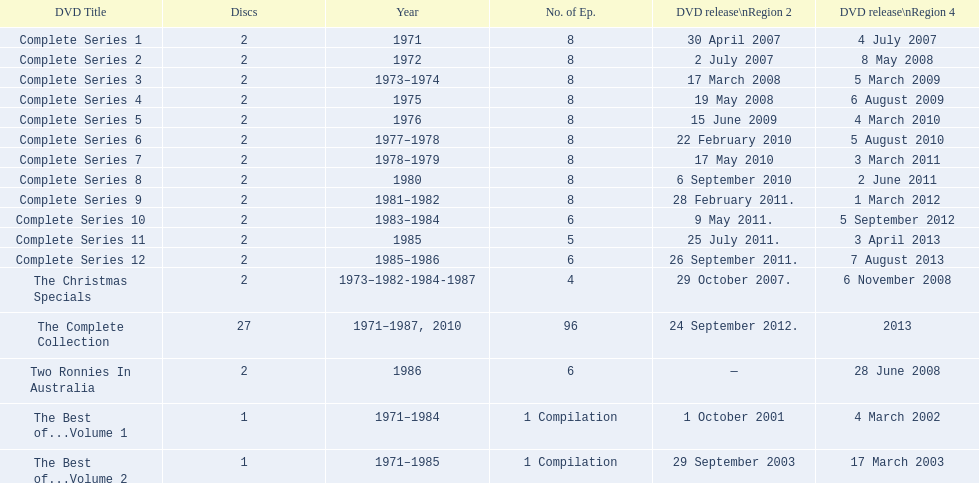How many series had 8 episodes? 9. 